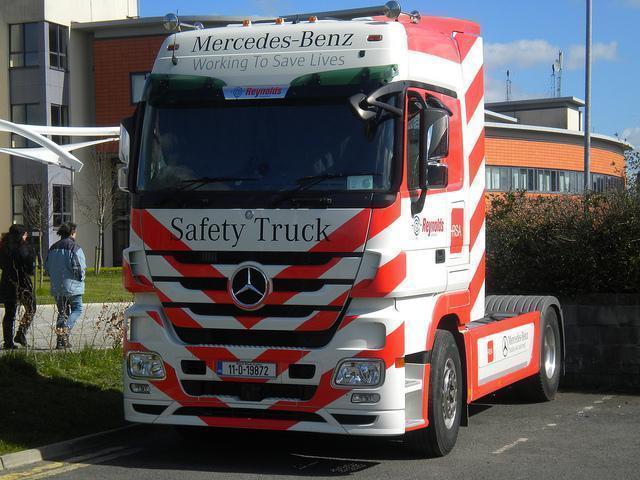What is the most appropriate surface for this truck to drive on?
Choose the right answer and clarify with the format: 'Answer: answer
Rationale: rationale.'
Options: Grass, asphalt, sidewalk, concrete. Answer: asphalt.
Rationale: The best place would be on a black top driveway Why does it say safety truck?
Indicate the correct response by choosing from the four available options to answer the question.
Options: Is safe, sell trucks, for sale, is stolen. Sell trucks. 